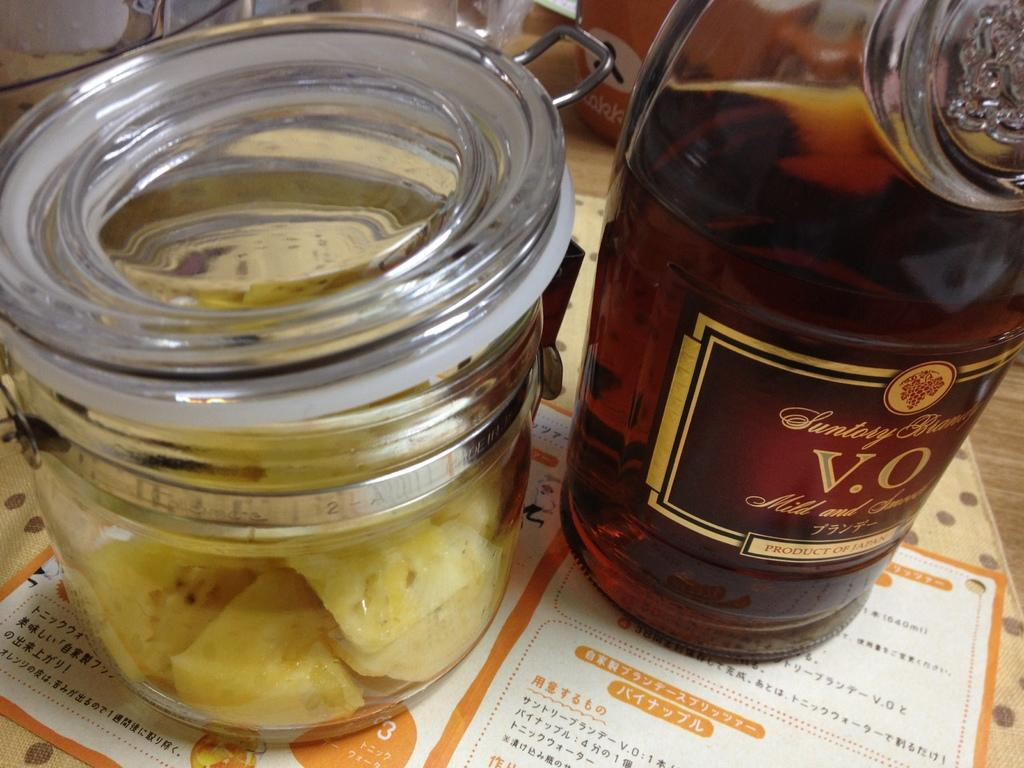What is in the bottle that is visible in the image? There is a wine bottle in the image, and it contains wine. What other food item can be seen in the image? There is a jar of food in the image. Where is the jar of food located? The jar of food is placed on a table. What might be used for selecting dishes in the image? There is a menu card in the image, which might be used for selecting dishes. Where is the menu card located? The menu card is placed on a table. What can be seen in the background of the image? There are objects in the background of the image. How many boats are visible in the image? There are no boats present in the image. What type of face can be seen on the wine bottle in the image? There is no face present on the wine bottle in the image. 